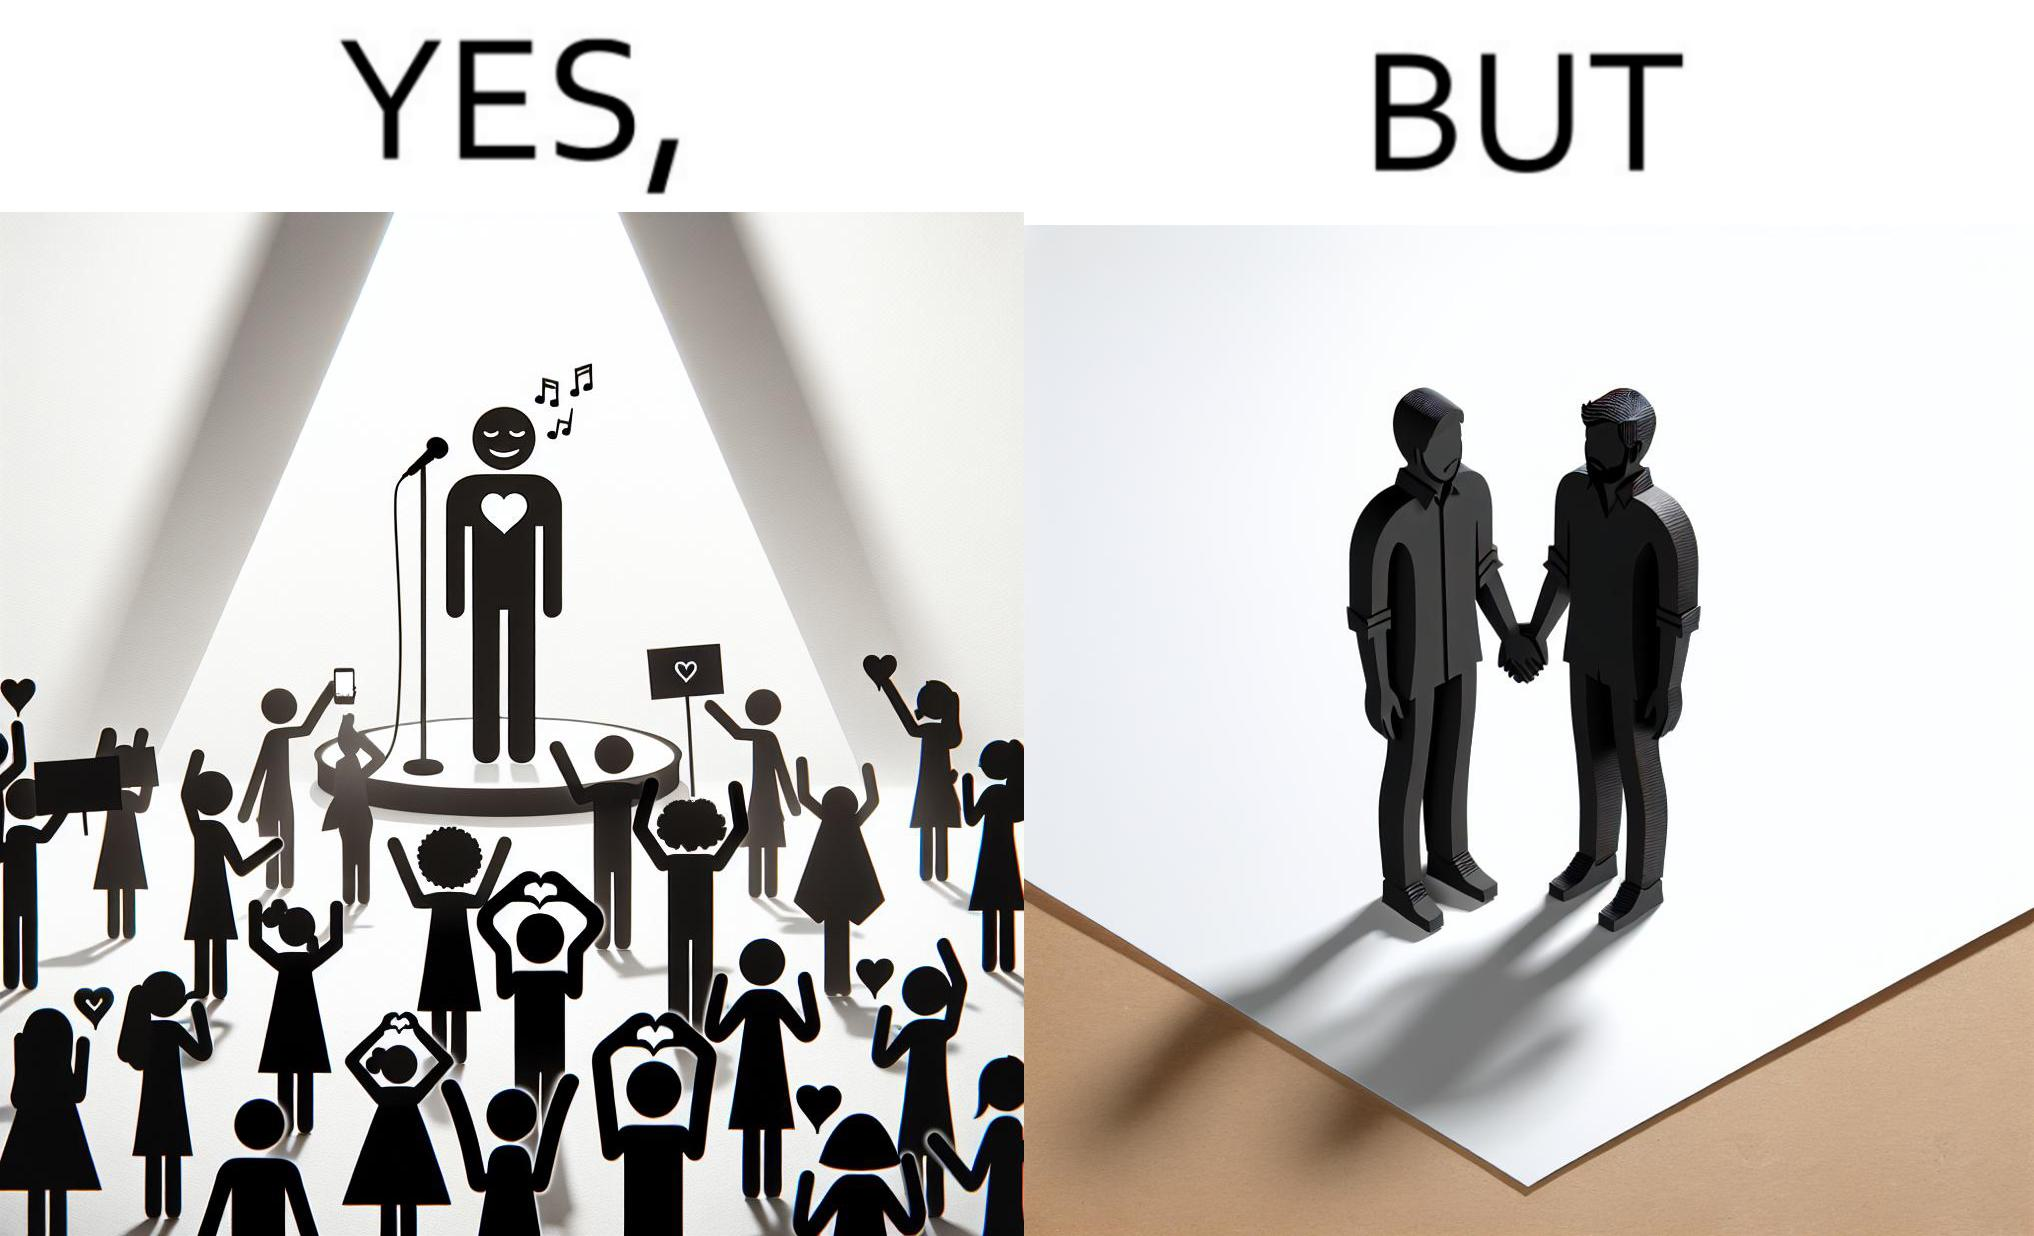Does this image contain satire or humor? Yes, this image is satirical. 